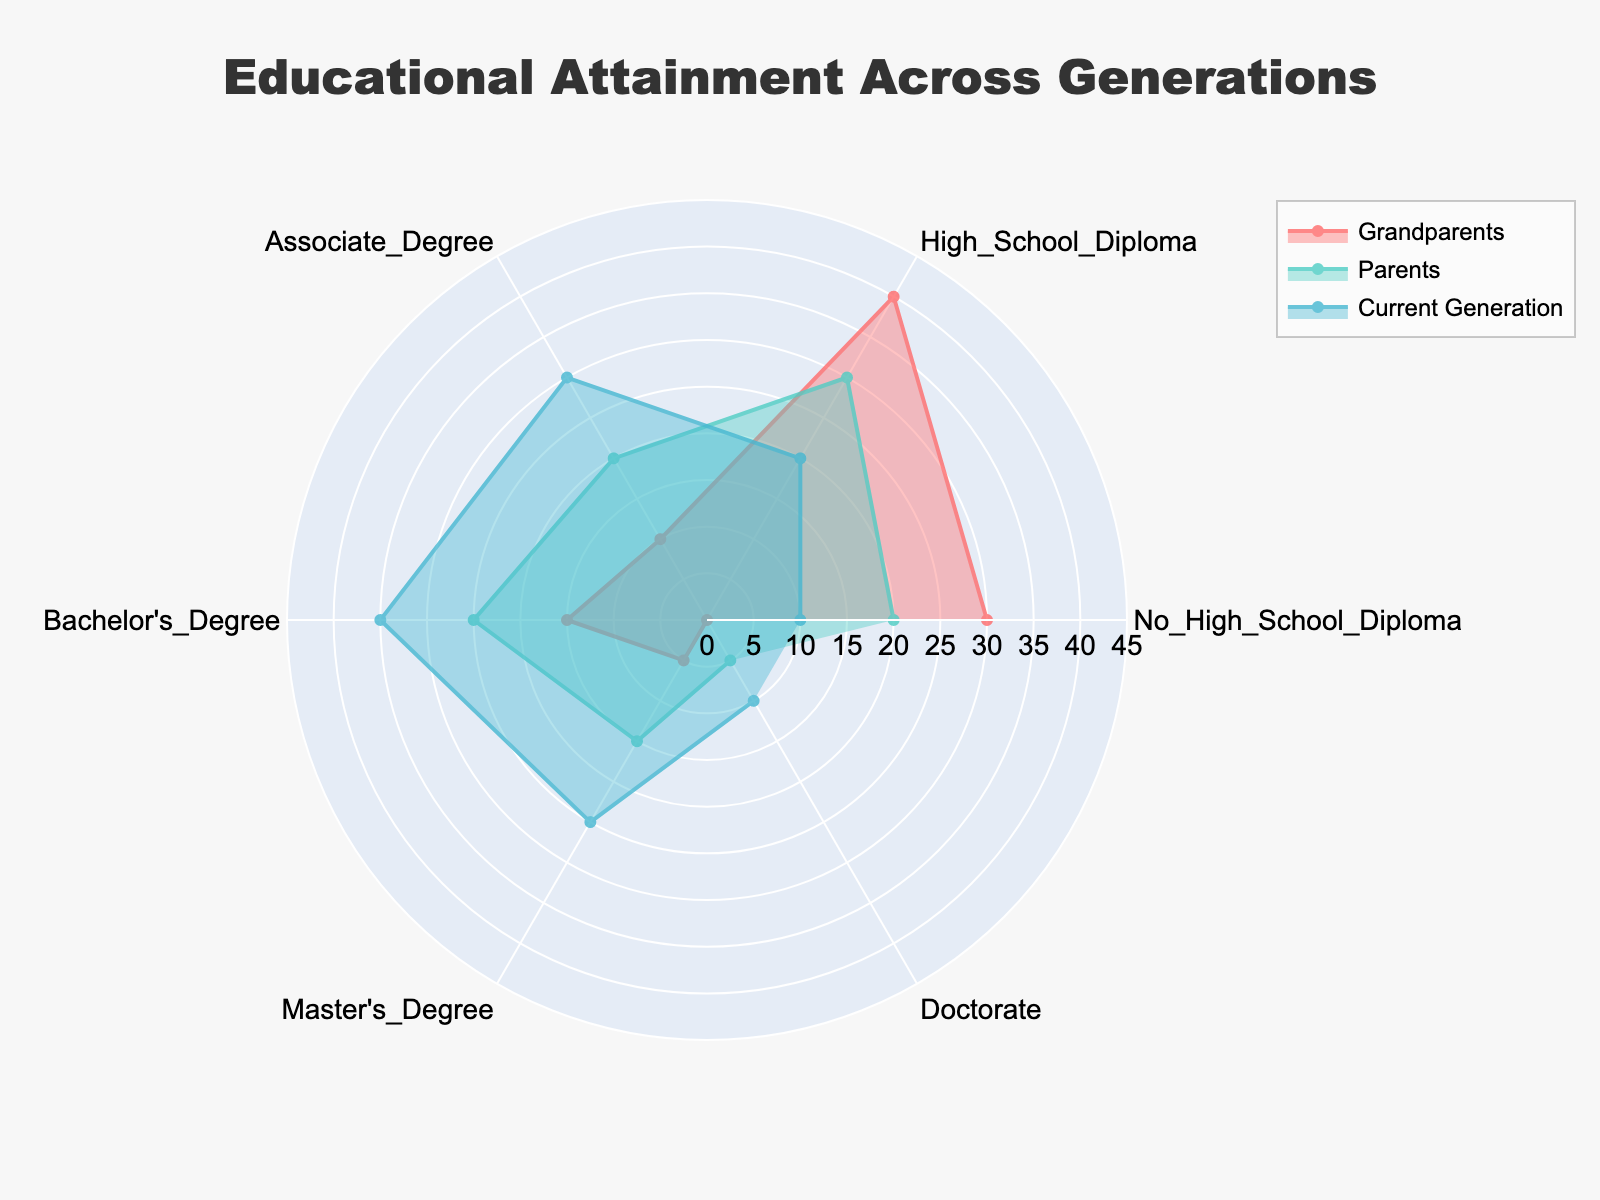What is the title of the radar chart? The title of the radar chart is usually displayed prominently at the top. In this case, the given data and code specify the title as "Educational Attainment Across Generations".
Answer: Educational Attainment Across Generations Which generational group has the highest percentage with a Bachelor's Degree? By inspecting the radar chart, we look at the Bachelor's Degree segment and compare the values of Grandparents, Parents, and Current Generation. The Current Generation has the highest value at 35%.
Answer: Current Generation How does the percentage of people with no high school diploma compare between grandparents and the current generation? Look at the values for the "No High School Diploma" category for both the Grandparents and Current Generation. Grandparents have 30%, while the Current Generation has 10%. To compare: 30% (Grandparents) is greater than 10% (Current Generation).
Answer: Grandparents have 20% more than the Current Generation What is the combined percentage of Master's Degrees and Doctorates for Parents? Add the percentage values for Master's Degrees and Doctorates for the Parents category. These values are 15% and 5%, respectively. So, 15 + 5 = 20%.
Answer: 20% Which educational level saw the most significant increase from Grandparents to Current Generation? Compare the values for each educational level between Grandparents and Current Generation to identify the greatest increase. The Bachelor's Degree went from 15% (Grandparents) to 35% (Current Generation), an increase of 20%.
Answer: Bachelor's Degree What is the range for the radial axis in the radar chart? The radial axis range is set to accommodate the highest value plus a buffer. The highest value in all three groups is 35% for the Current Generation's Bachelor's Degree. The chart range is 0 to 40% (considering a buffer).
Answer: 0 to 40% Between which two educational levels does the Current Generation have the smallest difference in percentage? Calculate the differences between consecutive educational levels for the Current Generation. The smallest difference is between Master's Degree (25%) and Bachelor's Degree (35%), which is 10%.
Answer: Master's Degree and Bachelor's Degree What educational level is equal in percentage for Grandparents and Parents? By checking the values for each educational level, we see that the Associate Degree is 10% for Grandparents and 20% for Parents—no levels match identically.
Answer: None 